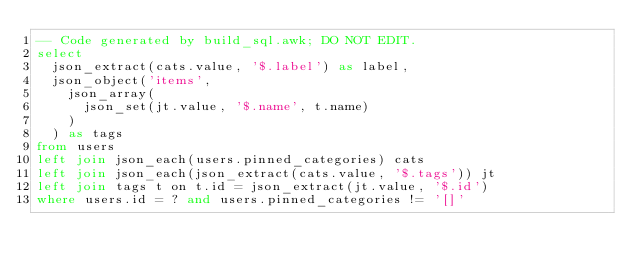Convert code to text. <code><loc_0><loc_0><loc_500><loc_500><_SQL_>-- Code generated by build_sql.awk; DO NOT EDIT.
select
  json_extract(cats.value, '$.label') as label,
  json_object('items',
    json_array(
      json_set(jt.value, '$.name', t.name)
    )
  ) as tags
from users
left join json_each(users.pinned_categories) cats
left join json_each(json_extract(cats.value, '$.tags')) jt
left join tags t on t.id = json_extract(jt.value, '$.id')
where users.id = ? and users.pinned_categories != '[]'
</code> 